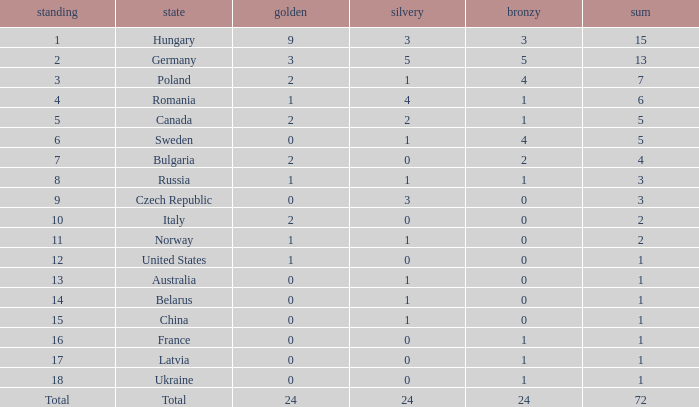How many golds have 3 as the rank, with a total greater than 7? 0.0. 